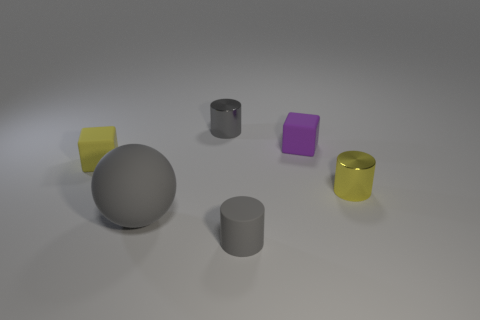Add 1 tiny red rubber things. How many objects exist? 7 Subtract all spheres. How many objects are left? 5 Add 3 small yellow blocks. How many small yellow blocks exist? 4 Subtract 0 blue cubes. How many objects are left? 6 Subtract all tiny gray rubber cylinders. Subtract all balls. How many objects are left? 4 Add 4 big rubber spheres. How many big rubber spheres are left? 5 